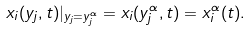<formula> <loc_0><loc_0><loc_500><loc_500>x _ { i } ( y _ { j } , t ) | _ { y _ { j } = y _ { j } ^ { \alpha } } = x _ { i } ( y _ { j } ^ { \alpha } , t ) = x _ { i } ^ { \alpha } ( t ) .</formula> 